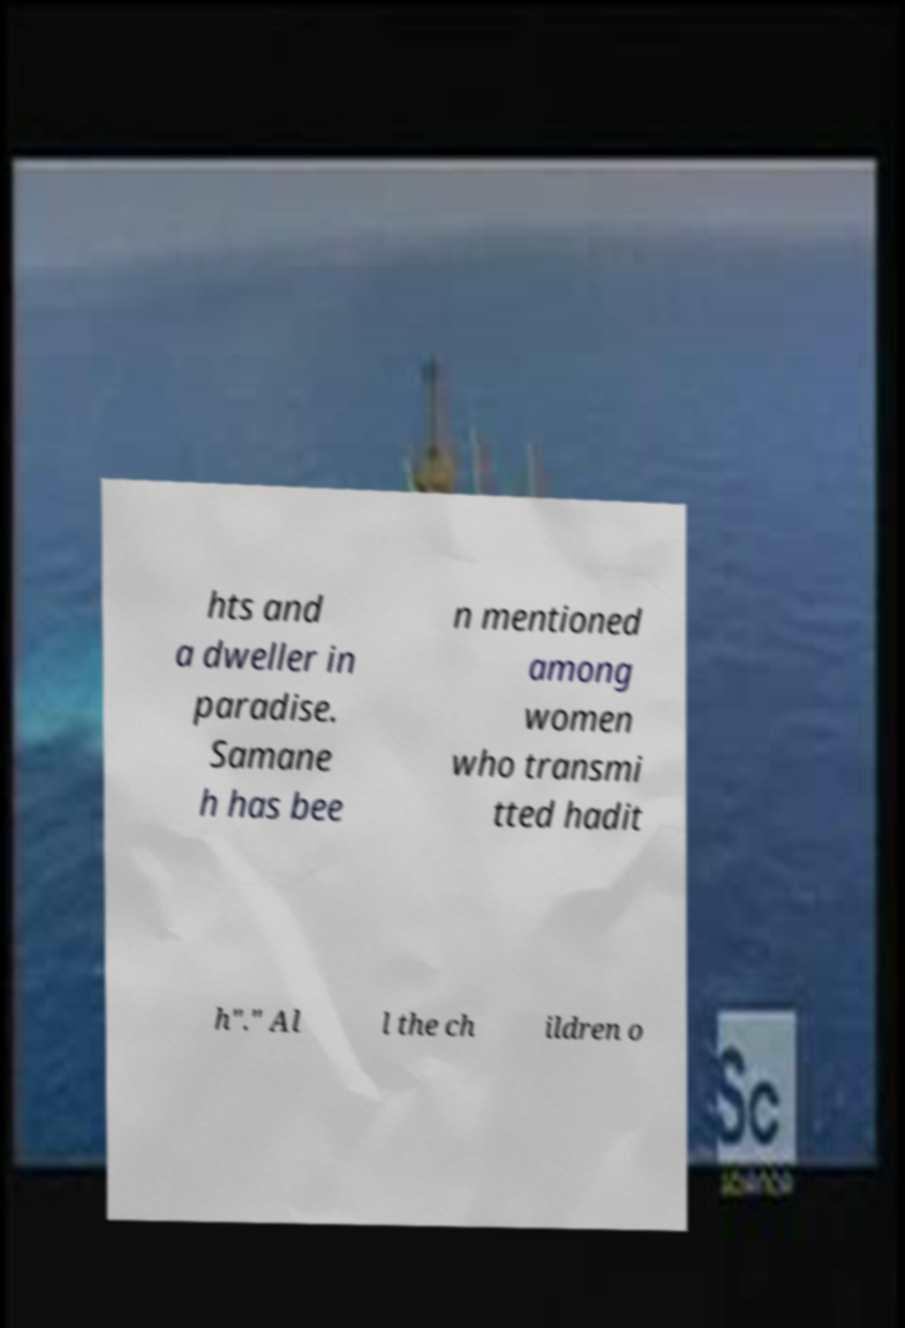What messages or text are displayed in this image? I need them in a readable, typed format. hts and a dweller in paradise. Samane h has bee n mentioned among women who transmi tted hadit h"." Al l the ch ildren o 